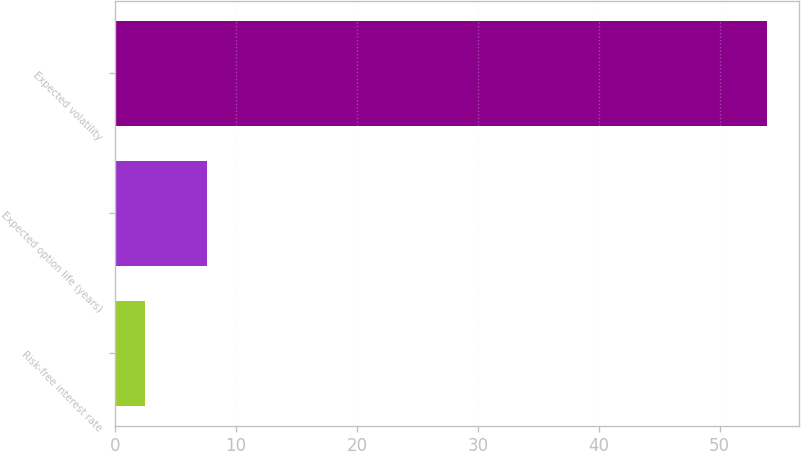Convert chart. <chart><loc_0><loc_0><loc_500><loc_500><bar_chart><fcel>Risk-free interest rate<fcel>Expected option life (years)<fcel>Expected volatility<nl><fcel>2.45<fcel>7.59<fcel>53.9<nl></chart> 